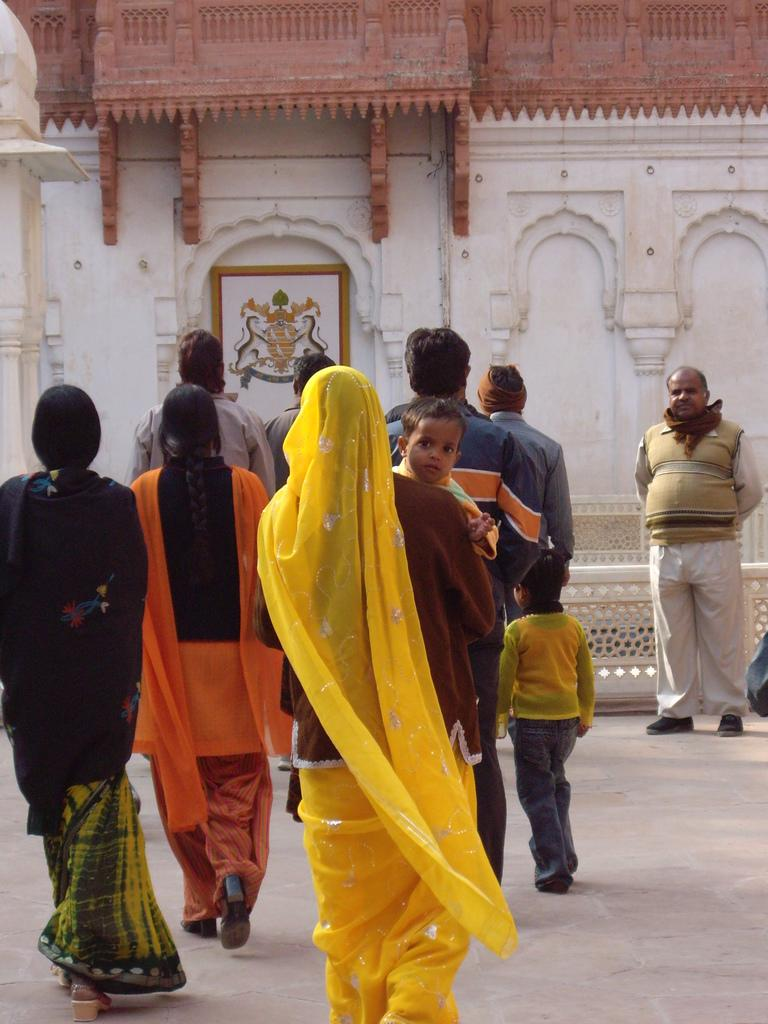What are the people in the image doing? The persons in the image are walking on the ground. Can you describe the woman in the image? The woman is carrying a kid in her hands. What can be seen in the background of the image? There is a frame and a design on the wall in the background. What type of hose is being used by the woman to carry the kid in the image? There is no hose present in the image; the woman is carrying the kid in her hands. What kind of silk material is visible on the wall in the image? There is no silk material visible on the wall in the image; it has a design, but the material is not specified. 